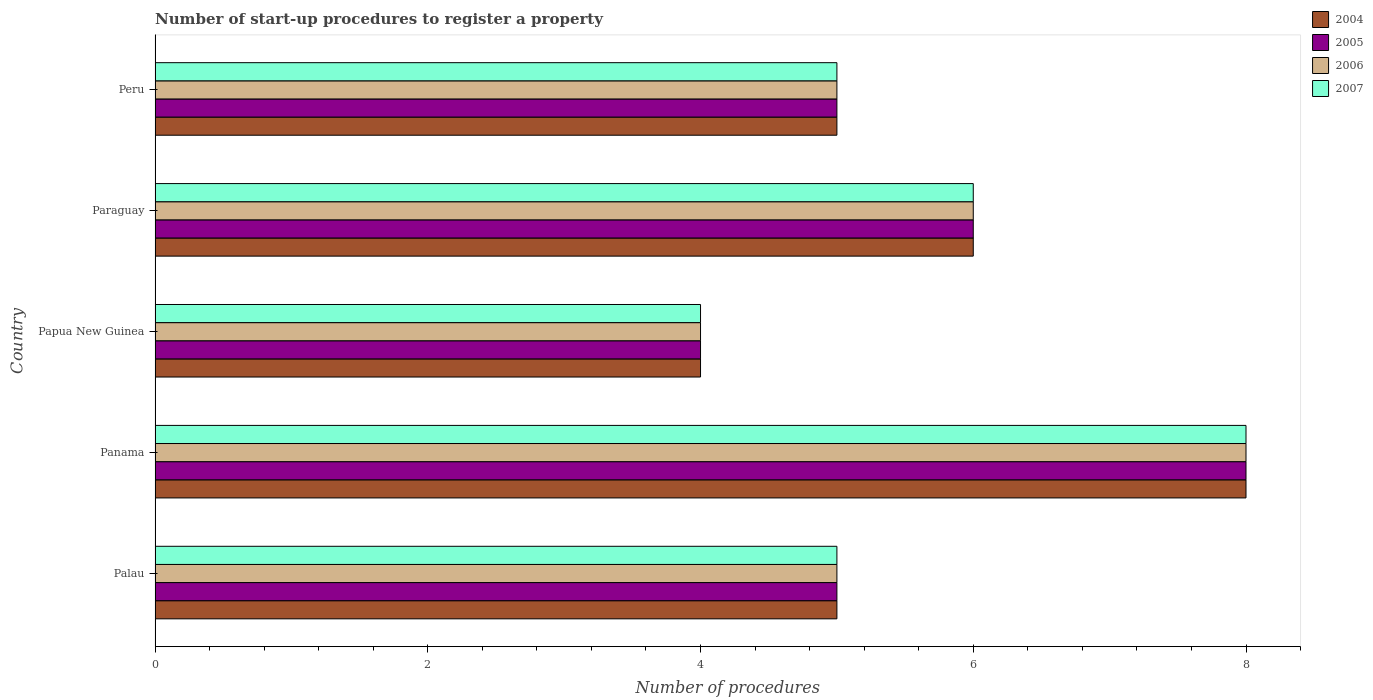How many different coloured bars are there?
Your response must be concise. 4. Are the number of bars on each tick of the Y-axis equal?
Provide a succinct answer. Yes. How many bars are there on the 2nd tick from the top?
Provide a succinct answer. 4. How many bars are there on the 1st tick from the bottom?
Your response must be concise. 4. What is the label of the 4th group of bars from the top?
Ensure brevity in your answer.  Panama. Across all countries, what is the minimum number of procedures required to register a property in 2007?
Your response must be concise. 4. In which country was the number of procedures required to register a property in 2005 maximum?
Ensure brevity in your answer.  Panama. In which country was the number of procedures required to register a property in 2004 minimum?
Give a very brief answer. Papua New Guinea. What is the difference between the number of procedures required to register a property in 2005 in Panama and the number of procedures required to register a property in 2007 in Paraguay?
Offer a terse response. 2. What is the average number of procedures required to register a property in 2007 per country?
Your response must be concise. 5.6. What is the difference between the number of procedures required to register a property in 2007 and number of procedures required to register a property in 2005 in Palau?
Give a very brief answer. 0. In how many countries, is the number of procedures required to register a property in 2007 greater than 1.2000000000000002 ?
Provide a succinct answer. 5. What is the ratio of the number of procedures required to register a property in 2006 in Panama to that in Papua New Guinea?
Provide a short and direct response. 2. Is the difference between the number of procedures required to register a property in 2007 in Panama and Peru greater than the difference between the number of procedures required to register a property in 2005 in Panama and Peru?
Your answer should be very brief. No. What is the difference between the highest and the second highest number of procedures required to register a property in 2007?
Provide a short and direct response. 2. In how many countries, is the number of procedures required to register a property in 2006 greater than the average number of procedures required to register a property in 2006 taken over all countries?
Provide a succinct answer. 2. Is the sum of the number of procedures required to register a property in 2006 in Panama and Papua New Guinea greater than the maximum number of procedures required to register a property in 2007 across all countries?
Keep it short and to the point. Yes. Are all the bars in the graph horizontal?
Ensure brevity in your answer.  Yes. Does the graph contain grids?
Your answer should be compact. No. Where does the legend appear in the graph?
Your response must be concise. Top right. How are the legend labels stacked?
Give a very brief answer. Vertical. What is the title of the graph?
Provide a short and direct response. Number of start-up procedures to register a property. What is the label or title of the X-axis?
Offer a very short reply. Number of procedures. What is the label or title of the Y-axis?
Your answer should be compact. Country. What is the Number of procedures in 2005 in Palau?
Give a very brief answer. 5. What is the Number of procedures in 2006 in Palau?
Offer a very short reply. 5. What is the Number of procedures of 2004 in Panama?
Keep it short and to the point. 8. What is the Number of procedures in 2005 in Panama?
Make the answer very short. 8. What is the Number of procedures in 2004 in Papua New Guinea?
Your answer should be very brief. 4. What is the Number of procedures of 2005 in Papua New Guinea?
Provide a succinct answer. 4. What is the Number of procedures of 2006 in Papua New Guinea?
Keep it short and to the point. 4. What is the Number of procedures in 2007 in Paraguay?
Keep it short and to the point. 6. What is the Number of procedures in 2004 in Peru?
Ensure brevity in your answer.  5. What is the Number of procedures in 2007 in Peru?
Make the answer very short. 5. Across all countries, what is the maximum Number of procedures in 2005?
Keep it short and to the point. 8. Across all countries, what is the maximum Number of procedures of 2006?
Offer a very short reply. 8. Across all countries, what is the maximum Number of procedures of 2007?
Your answer should be very brief. 8. What is the total Number of procedures of 2006 in the graph?
Offer a terse response. 28. What is the total Number of procedures of 2007 in the graph?
Give a very brief answer. 28. What is the difference between the Number of procedures in 2006 in Palau and that in Panama?
Give a very brief answer. -3. What is the difference between the Number of procedures in 2007 in Palau and that in Panama?
Offer a terse response. -3. What is the difference between the Number of procedures in 2004 in Palau and that in Papua New Guinea?
Offer a terse response. 1. What is the difference between the Number of procedures in 2005 in Palau and that in Papua New Guinea?
Your answer should be very brief. 1. What is the difference between the Number of procedures in 2007 in Palau and that in Papua New Guinea?
Make the answer very short. 1. What is the difference between the Number of procedures of 2007 in Palau and that in Paraguay?
Provide a succinct answer. -1. What is the difference between the Number of procedures of 2004 in Palau and that in Peru?
Provide a succinct answer. 0. What is the difference between the Number of procedures of 2005 in Panama and that in Paraguay?
Your answer should be compact. 2. What is the difference between the Number of procedures in 2004 in Panama and that in Peru?
Your response must be concise. 3. What is the difference between the Number of procedures in 2004 in Papua New Guinea and that in Paraguay?
Your answer should be very brief. -2. What is the difference between the Number of procedures in 2005 in Papua New Guinea and that in Paraguay?
Give a very brief answer. -2. What is the difference between the Number of procedures in 2006 in Papua New Guinea and that in Paraguay?
Keep it short and to the point. -2. What is the difference between the Number of procedures of 2005 in Papua New Guinea and that in Peru?
Make the answer very short. -1. What is the difference between the Number of procedures in 2006 in Papua New Guinea and that in Peru?
Offer a terse response. -1. What is the difference between the Number of procedures of 2004 in Palau and the Number of procedures of 2006 in Panama?
Give a very brief answer. -3. What is the difference between the Number of procedures of 2004 in Palau and the Number of procedures of 2007 in Panama?
Keep it short and to the point. -3. What is the difference between the Number of procedures in 2005 in Palau and the Number of procedures in 2006 in Panama?
Your answer should be compact. -3. What is the difference between the Number of procedures in 2005 in Palau and the Number of procedures in 2007 in Panama?
Make the answer very short. -3. What is the difference between the Number of procedures in 2004 in Palau and the Number of procedures in 2005 in Papua New Guinea?
Provide a short and direct response. 1. What is the difference between the Number of procedures in 2004 in Palau and the Number of procedures in 2007 in Papua New Guinea?
Offer a terse response. 1. What is the difference between the Number of procedures of 2005 in Palau and the Number of procedures of 2007 in Papua New Guinea?
Provide a succinct answer. 1. What is the difference between the Number of procedures in 2006 in Palau and the Number of procedures in 2007 in Papua New Guinea?
Keep it short and to the point. 1. What is the difference between the Number of procedures in 2004 in Palau and the Number of procedures in 2007 in Paraguay?
Your answer should be compact. -1. What is the difference between the Number of procedures in 2005 in Palau and the Number of procedures in 2007 in Paraguay?
Your answer should be compact. -1. What is the difference between the Number of procedures in 2006 in Palau and the Number of procedures in 2007 in Paraguay?
Your response must be concise. -1. What is the difference between the Number of procedures of 2004 in Palau and the Number of procedures of 2005 in Peru?
Keep it short and to the point. 0. What is the difference between the Number of procedures in 2004 in Palau and the Number of procedures in 2006 in Peru?
Make the answer very short. 0. What is the difference between the Number of procedures of 2006 in Palau and the Number of procedures of 2007 in Peru?
Offer a terse response. 0. What is the difference between the Number of procedures of 2004 in Panama and the Number of procedures of 2006 in Papua New Guinea?
Make the answer very short. 4. What is the difference between the Number of procedures in 2005 in Panama and the Number of procedures in 2006 in Papua New Guinea?
Make the answer very short. 4. What is the difference between the Number of procedures of 2005 in Panama and the Number of procedures of 2007 in Papua New Guinea?
Your response must be concise. 4. What is the difference between the Number of procedures in 2004 in Panama and the Number of procedures in 2005 in Paraguay?
Your answer should be very brief. 2. What is the difference between the Number of procedures of 2004 in Panama and the Number of procedures of 2007 in Paraguay?
Make the answer very short. 2. What is the difference between the Number of procedures of 2005 in Panama and the Number of procedures of 2006 in Paraguay?
Your response must be concise. 2. What is the difference between the Number of procedures in 2006 in Panama and the Number of procedures in 2007 in Paraguay?
Make the answer very short. 2. What is the difference between the Number of procedures in 2004 in Panama and the Number of procedures in 2005 in Peru?
Offer a terse response. 3. What is the difference between the Number of procedures of 2004 in Panama and the Number of procedures of 2007 in Peru?
Your answer should be very brief. 3. What is the difference between the Number of procedures in 2005 in Panama and the Number of procedures in 2006 in Peru?
Make the answer very short. 3. What is the difference between the Number of procedures of 2005 in Panama and the Number of procedures of 2007 in Peru?
Provide a short and direct response. 3. What is the difference between the Number of procedures of 2004 in Papua New Guinea and the Number of procedures of 2006 in Paraguay?
Make the answer very short. -2. What is the difference between the Number of procedures in 2004 in Papua New Guinea and the Number of procedures in 2006 in Peru?
Keep it short and to the point. -1. What is the difference between the Number of procedures in 2005 in Papua New Guinea and the Number of procedures in 2006 in Peru?
Provide a succinct answer. -1. What is the difference between the Number of procedures in 2004 in Paraguay and the Number of procedures in 2005 in Peru?
Your answer should be compact. 1. What is the difference between the Number of procedures in 2005 in Paraguay and the Number of procedures in 2007 in Peru?
Provide a succinct answer. 1. What is the average Number of procedures in 2007 per country?
Give a very brief answer. 5.6. What is the difference between the Number of procedures of 2004 and Number of procedures of 2006 in Palau?
Offer a very short reply. 0. What is the difference between the Number of procedures in 2004 and Number of procedures in 2007 in Palau?
Your answer should be very brief. 0. What is the difference between the Number of procedures of 2005 and Number of procedures of 2006 in Palau?
Provide a short and direct response. 0. What is the difference between the Number of procedures in 2006 and Number of procedures in 2007 in Palau?
Make the answer very short. 0. What is the difference between the Number of procedures in 2004 and Number of procedures in 2005 in Panama?
Provide a short and direct response. 0. What is the difference between the Number of procedures of 2004 and Number of procedures of 2006 in Panama?
Your response must be concise. 0. What is the difference between the Number of procedures of 2004 and Number of procedures of 2007 in Panama?
Your response must be concise. 0. What is the difference between the Number of procedures of 2005 and Number of procedures of 2007 in Panama?
Ensure brevity in your answer.  0. What is the difference between the Number of procedures of 2006 and Number of procedures of 2007 in Panama?
Make the answer very short. 0. What is the difference between the Number of procedures of 2004 and Number of procedures of 2005 in Papua New Guinea?
Your answer should be compact. 0. What is the difference between the Number of procedures of 2005 and Number of procedures of 2006 in Papua New Guinea?
Make the answer very short. 0. What is the difference between the Number of procedures of 2005 and Number of procedures of 2007 in Papua New Guinea?
Your answer should be very brief. 0. What is the difference between the Number of procedures of 2006 and Number of procedures of 2007 in Papua New Guinea?
Provide a short and direct response. 0. What is the difference between the Number of procedures in 2004 and Number of procedures in 2005 in Paraguay?
Your answer should be very brief. 0. What is the difference between the Number of procedures in 2004 and Number of procedures in 2006 in Paraguay?
Give a very brief answer. 0. What is the difference between the Number of procedures of 2004 and Number of procedures of 2006 in Peru?
Offer a terse response. 0. What is the ratio of the Number of procedures of 2006 in Palau to that in Panama?
Ensure brevity in your answer.  0.62. What is the ratio of the Number of procedures in 2007 in Palau to that in Panama?
Provide a succinct answer. 0.62. What is the ratio of the Number of procedures of 2004 in Palau to that in Papua New Guinea?
Provide a succinct answer. 1.25. What is the ratio of the Number of procedures of 2006 in Palau to that in Papua New Guinea?
Ensure brevity in your answer.  1.25. What is the ratio of the Number of procedures in 2004 in Palau to that in Paraguay?
Your answer should be compact. 0.83. What is the ratio of the Number of procedures of 2005 in Palau to that in Paraguay?
Offer a very short reply. 0.83. What is the ratio of the Number of procedures of 2006 in Palau to that in Paraguay?
Provide a succinct answer. 0.83. What is the ratio of the Number of procedures in 2004 in Palau to that in Peru?
Give a very brief answer. 1. What is the ratio of the Number of procedures in 2005 in Palau to that in Peru?
Make the answer very short. 1. What is the ratio of the Number of procedures in 2007 in Palau to that in Peru?
Give a very brief answer. 1. What is the ratio of the Number of procedures in 2005 in Panama to that in Papua New Guinea?
Make the answer very short. 2. What is the ratio of the Number of procedures in 2006 in Panama to that in Papua New Guinea?
Your response must be concise. 2. What is the ratio of the Number of procedures in 2007 in Panama to that in Papua New Guinea?
Keep it short and to the point. 2. What is the ratio of the Number of procedures in 2004 in Panama to that in Paraguay?
Keep it short and to the point. 1.33. What is the ratio of the Number of procedures of 2005 in Panama to that in Paraguay?
Provide a short and direct response. 1.33. What is the ratio of the Number of procedures of 2005 in Panama to that in Peru?
Your response must be concise. 1.6. What is the ratio of the Number of procedures in 2007 in Panama to that in Peru?
Ensure brevity in your answer.  1.6. What is the ratio of the Number of procedures of 2005 in Papua New Guinea to that in Paraguay?
Give a very brief answer. 0.67. What is the ratio of the Number of procedures in 2007 in Papua New Guinea to that in Paraguay?
Offer a very short reply. 0.67. What is the ratio of the Number of procedures of 2006 in Papua New Guinea to that in Peru?
Offer a very short reply. 0.8. What is the ratio of the Number of procedures of 2007 in Papua New Guinea to that in Peru?
Ensure brevity in your answer.  0.8. What is the ratio of the Number of procedures of 2004 in Paraguay to that in Peru?
Make the answer very short. 1.2. What is the ratio of the Number of procedures of 2006 in Paraguay to that in Peru?
Provide a succinct answer. 1.2. What is the difference between the highest and the second highest Number of procedures in 2004?
Your answer should be compact. 2. What is the difference between the highest and the second highest Number of procedures of 2005?
Your answer should be compact. 2. What is the difference between the highest and the second highest Number of procedures in 2007?
Give a very brief answer. 2. What is the difference between the highest and the lowest Number of procedures in 2004?
Offer a very short reply. 4. What is the difference between the highest and the lowest Number of procedures of 2005?
Keep it short and to the point. 4. What is the difference between the highest and the lowest Number of procedures of 2006?
Keep it short and to the point. 4. 